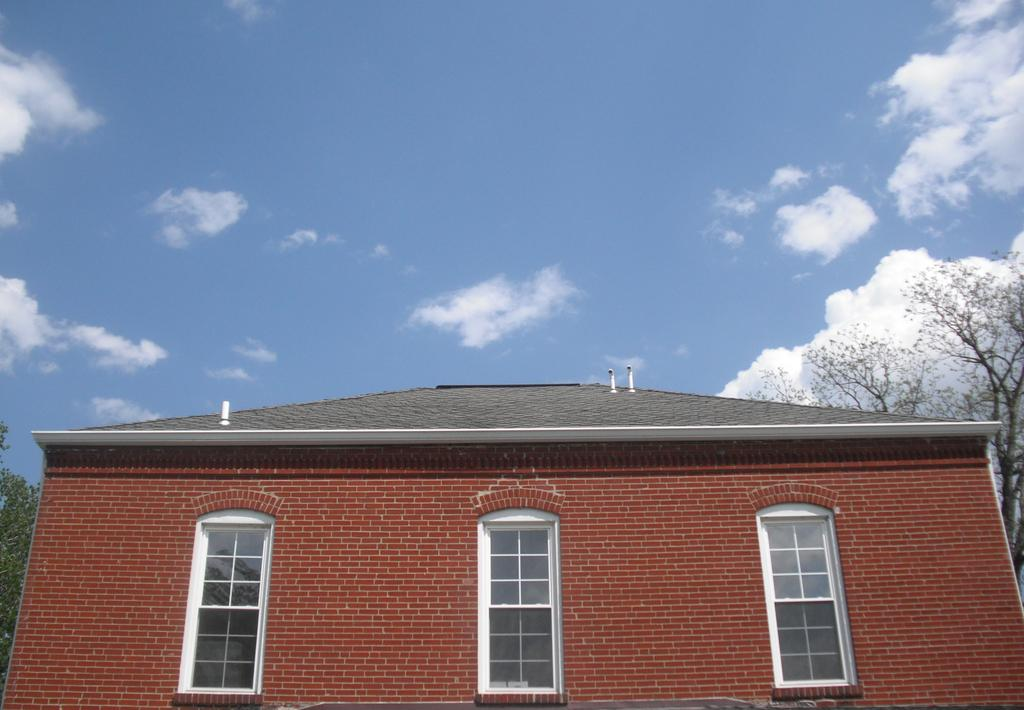What type of house is shown in the image? There is a house with glass windows in the image. What can be seen on either side of the house? There are trees on either side of the house. How would you describe the sky in the image? The sky is cloudy in the image. What hobbies are the trees on either side of the house engaged in? Trees do not have hobbies, as they are inanimate objects. 